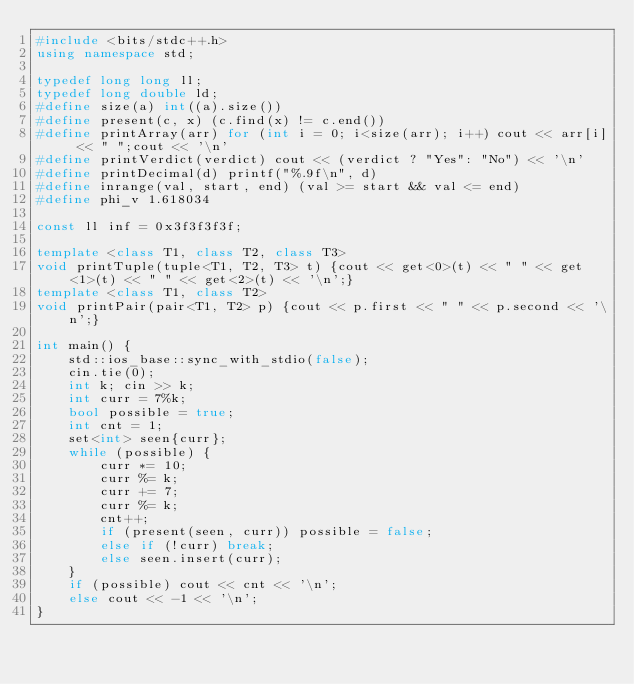<code> <loc_0><loc_0><loc_500><loc_500><_C++_>#include <bits/stdc++.h>
using namespace std;

typedef long long ll;
typedef long double ld;
#define size(a) int((a).size())
#define present(c, x) (c.find(x) != c.end()) 
#define printArray(arr) for (int i = 0; i<size(arr); i++) cout << arr[i] << " ";cout << '\n'
#define printVerdict(verdict) cout << (verdict ? "Yes": "No") << '\n'
#define printDecimal(d) printf("%.9f\n", d)
#define inrange(val, start, end) (val >= start && val <= end)
#define phi_v 1.618034

const ll inf = 0x3f3f3f3f;

template <class T1, class T2, class T3> 
void printTuple(tuple<T1, T2, T3> t) {cout << get<0>(t) << " " << get<1>(t) << " " << get<2>(t) << '\n';}
template <class T1, class T2>
void printPair(pair<T1, T2> p) {cout << p.first << " " << p.second << '\n';}

int main() {
	std::ios_base::sync_with_stdio(false);
	cin.tie(0);
	int k; cin >> k;
	int curr = 7%k;
	bool possible = true;
	int cnt = 1;
	set<int> seen{curr};
	while (possible) {
		curr *= 10;
		curr %= k;
		curr += 7;
		curr %= k;
		cnt++;
		if (present(seen, curr)) possible = false;
		else if (!curr) break;
		else seen.insert(curr);
	}
	if (possible) cout << cnt << '\n';
	else cout << -1 << '\n';
}
</code> 